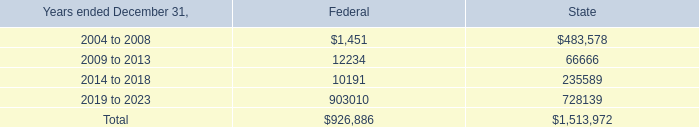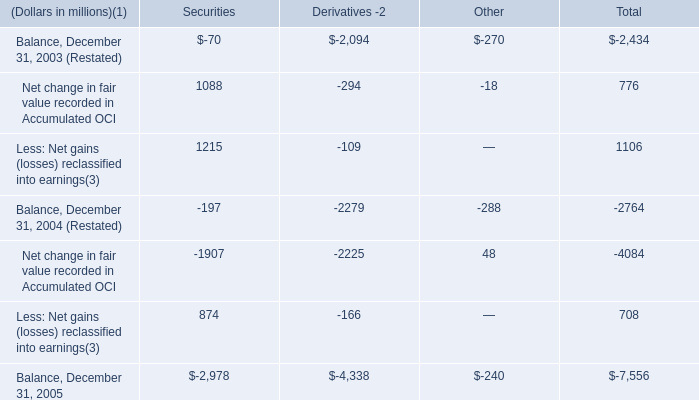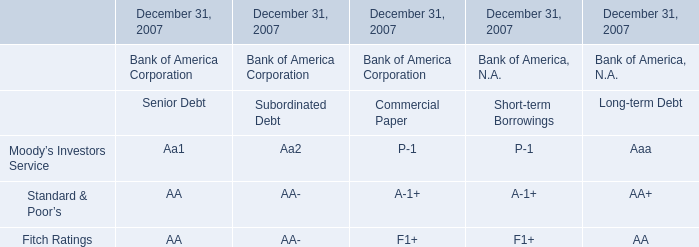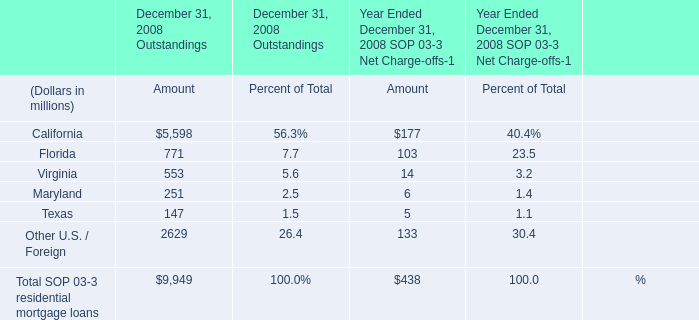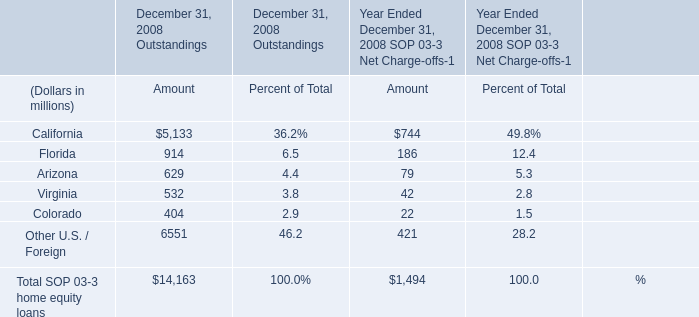What's the average of elements for Amount of December 31, 2008 Outstandings? (in million) 
Computations: (14163 / 6)
Answer: 2360.5. 